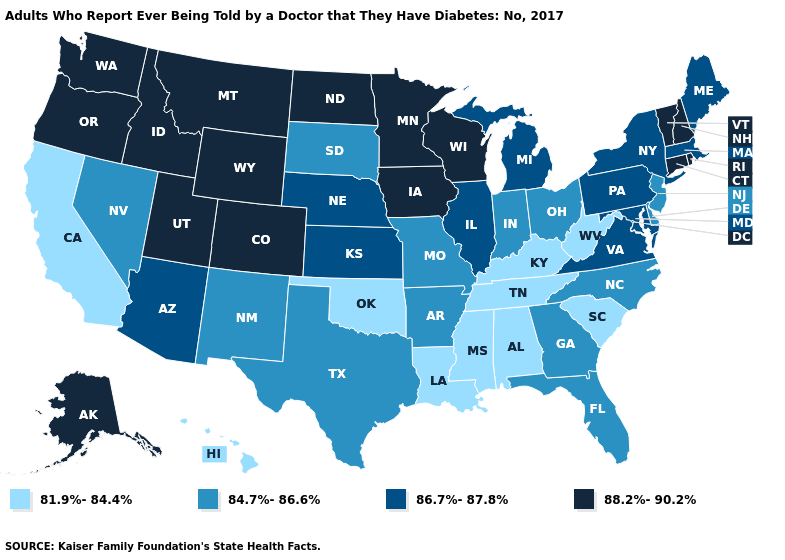How many symbols are there in the legend?
Give a very brief answer. 4. Name the states that have a value in the range 88.2%-90.2%?
Answer briefly. Alaska, Colorado, Connecticut, Idaho, Iowa, Minnesota, Montana, New Hampshire, North Dakota, Oregon, Rhode Island, Utah, Vermont, Washington, Wisconsin, Wyoming. Which states have the highest value in the USA?
Be succinct. Alaska, Colorado, Connecticut, Idaho, Iowa, Minnesota, Montana, New Hampshire, North Dakota, Oregon, Rhode Island, Utah, Vermont, Washington, Wisconsin, Wyoming. Does the first symbol in the legend represent the smallest category?
Short answer required. Yes. What is the highest value in states that border California?
Write a very short answer. 88.2%-90.2%. Among the states that border Missouri , which have the highest value?
Answer briefly. Iowa. Name the states that have a value in the range 81.9%-84.4%?
Short answer required. Alabama, California, Hawaii, Kentucky, Louisiana, Mississippi, Oklahoma, South Carolina, Tennessee, West Virginia. Does California have the highest value in the West?
Write a very short answer. No. What is the lowest value in the Northeast?
Write a very short answer. 84.7%-86.6%. What is the value of Alabama?
Give a very brief answer. 81.9%-84.4%. Does Tennessee have a lower value than Ohio?
Answer briefly. Yes. What is the value of Rhode Island?
Short answer required. 88.2%-90.2%. What is the lowest value in the South?
Quick response, please. 81.9%-84.4%. Name the states that have a value in the range 84.7%-86.6%?
Keep it brief. Arkansas, Delaware, Florida, Georgia, Indiana, Missouri, Nevada, New Jersey, New Mexico, North Carolina, Ohio, South Dakota, Texas. Which states have the lowest value in the USA?
Quick response, please. Alabama, California, Hawaii, Kentucky, Louisiana, Mississippi, Oklahoma, South Carolina, Tennessee, West Virginia. 